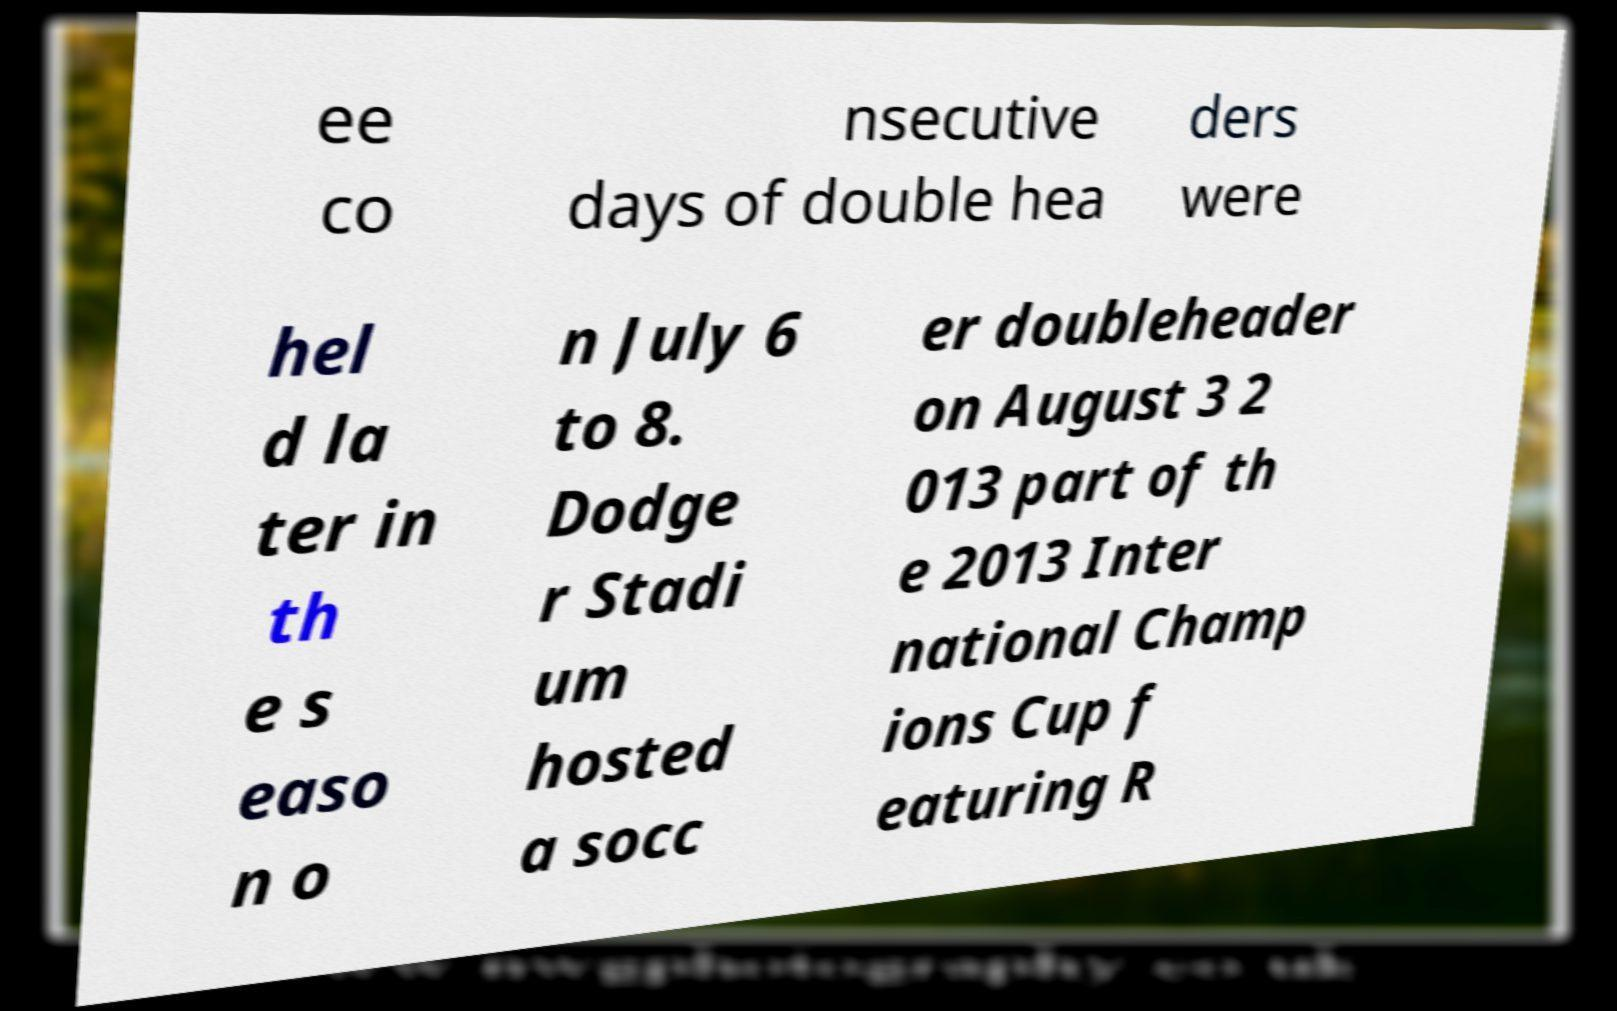Can you read and provide the text displayed in the image?This photo seems to have some interesting text. Can you extract and type it out for me? ee co nsecutive days of double hea ders were hel d la ter in th e s easo n o n July 6 to 8. Dodge r Stadi um hosted a socc er doubleheader on August 3 2 013 part of th e 2013 Inter national Champ ions Cup f eaturing R 